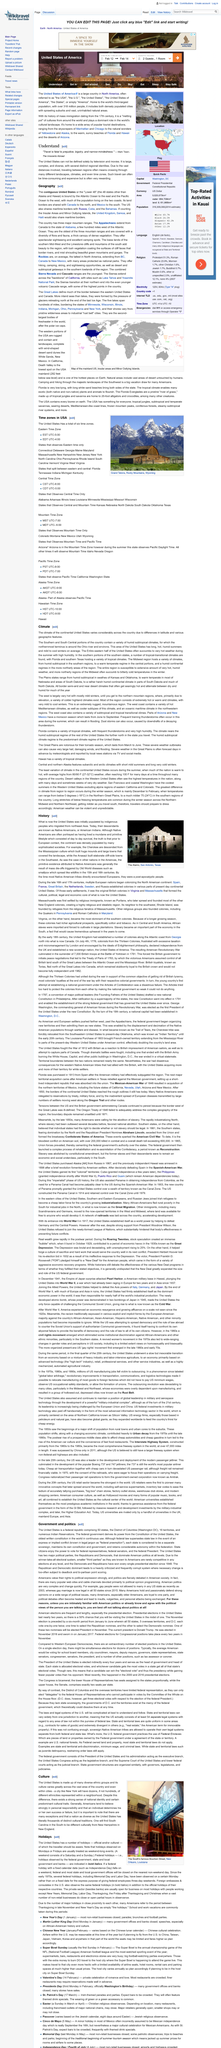Give some essential details in this illustration. Federal preemption refers to the principle where federal law overrides or takes precedence over state or local laws in certain areas, while express conflict occurs when there is a clear and explicit clash between two laws, and implied conflict arises when the two laws are ambiguous and can be interpreted in different ways to create a conflict. In the summer, the eastern half of the United States is prone to hot weather, characterized by high humidity, which afflicts the region extensively. It is a widely held belief among Americans that personal responsibility plays a significant role in an individual's success or failure, and that individuals are largely responsible for their own outcomes. New York City is known for its diverse ethnicities, with dozens, if not hundreds, of different ethnicities represented within its neighborhoods. The Midwest's northerly regions are known to experience extremely cold winters. 